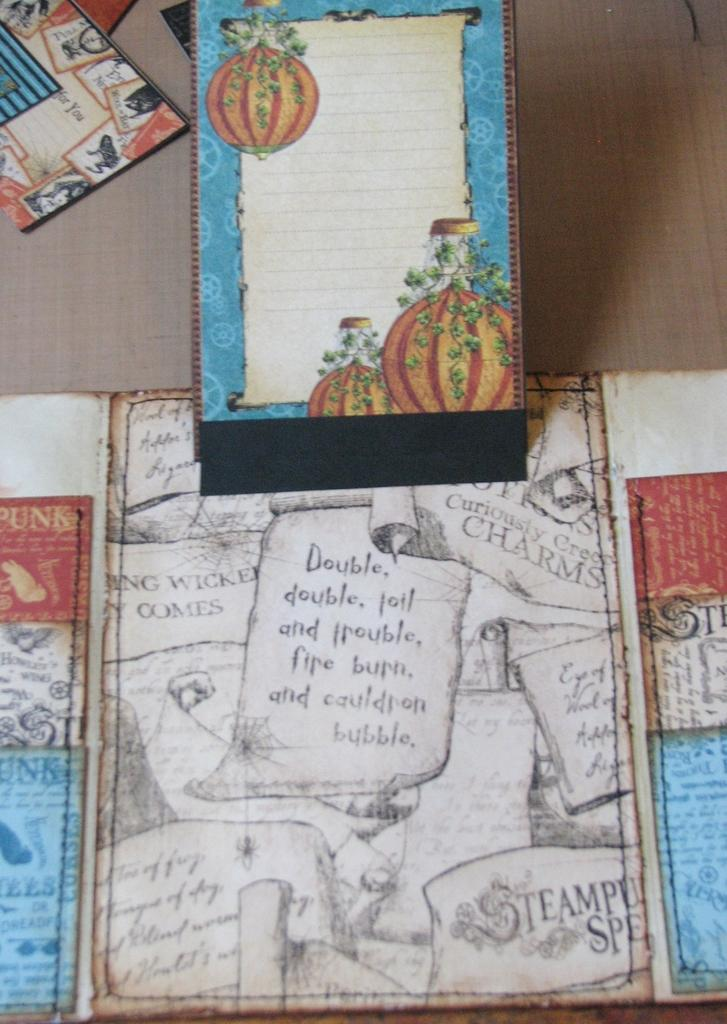What type of material can be seen in the image? There are papers in the image. What is the origin of the papers? The papers are from a book. What is featured in the book? The book contains paintings. Are there any written words in the book? Yes, there are words written on the book's pages. What type of seed can be seen growing on the book's pages? There is no seed present on the book's pages; the image features papers from a book containing paintings and written words. 